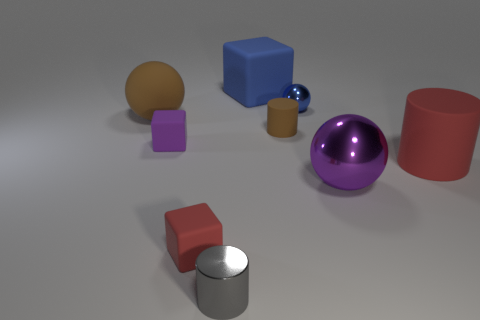Is there a tiny thing of the same color as the big rubber cylinder?
Your response must be concise. Yes. What size is the thing that is both behind the brown ball and to the left of the blue sphere?
Give a very brief answer. Large. The tiny purple matte object is what shape?
Keep it short and to the point. Cube. There is a matte thing on the right side of the tiny blue thing; is there a big thing to the left of it?
Offer a very short reply. Yes. There is a cube in front of the red cylinder; what number of big matte objects are left of it?
Keep it short and to the point. 1. There is a red thing that is the same size as the purple cube; what is its material?
Keep it short and to the point. Rubber. There is a matte thing that is in front of the big metallic ball; is its shape the same as the purple rubber thing?
Make the answer very short. Yes. Is the number of big balls in front of the big red object greater than the number of cylinders that are in front of the small gray thing?
Provide a succinct answer. Yes. How many gray objects have the same material as the blue ball?
Ensure brevity in your answer.  1. Do the brown matte cylinder and the gray cylinder have the same size?
Provide a short and direct response. Yes. 